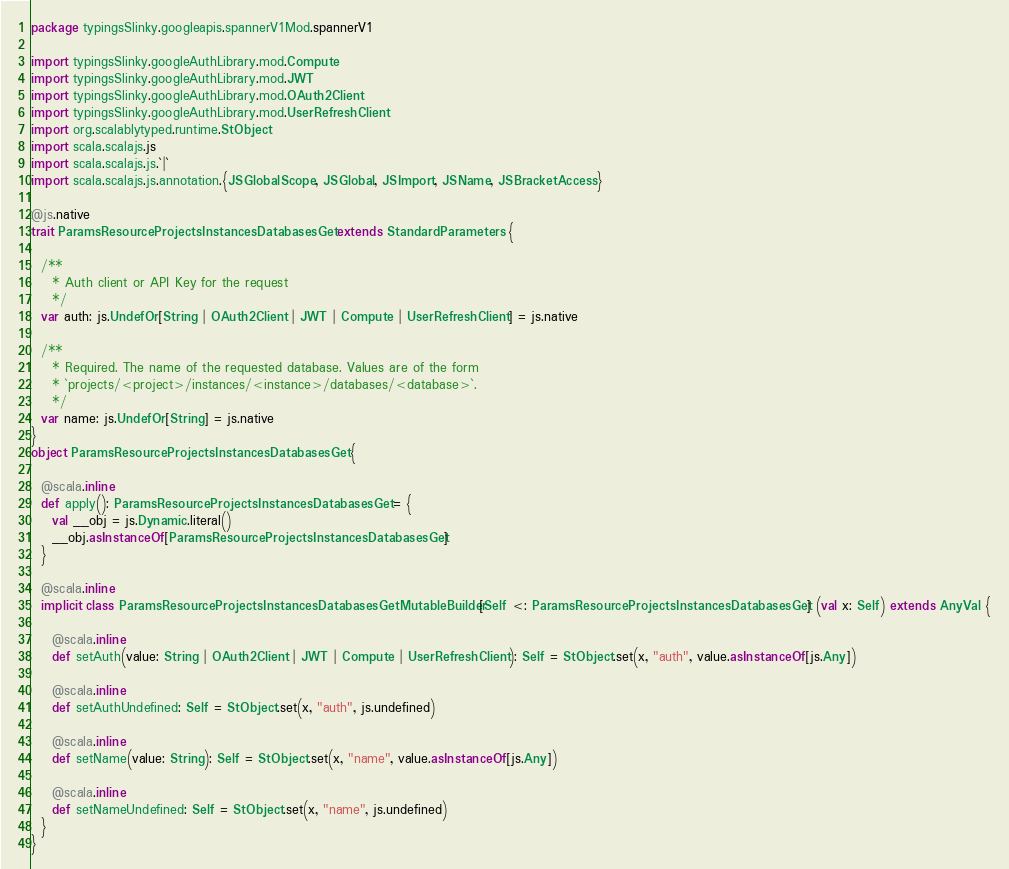<code> <loc_0><loc_0><loc_500><loc_500><_Scala_>package typingsSlinky.googleapis.spannerV1Mod.spannerV1

import typingsSlinky.googleAuthLibrary.mod.Compute
import typingsSlinky.googleAuthLibrary.mod.JWT
import typingsSlinky.googleAuthLibrary.mod.OAuth2Client
import typingsSlinky.googleAuthLibrary.mod.UserRefreshClient
import org.scalablytyped.runtime.StObject
import scala.scalajs.js
import scala.scalajs.js.`|`
import scala.scalajs.js.annotation.{JSGlobalScope, JSGlobal, JSImport, JSName, JSBracketAccess}

@js.native
trait ParamsResourceProjectsInstancesDatabasesGet extends StandardParameters {
  
  /**
    * Auth client or API Key for the request
    */
  var auth: js.UndefOr[String | OAuth2Client | JWT | Compute | UserRefreshClient] = js.native
  
  /**
    * Required. The name of the requested database. Values are of the form
    * `projects/<project>/instances/<instance>/databases/<database>`.
    */
  var name: js.UndefOr[String] = js.native
}
object ParamsResourceProjectsInstancesDatabasesGet {
  
  @scala.inline
  def apply(): ParamsResourceProjectsInstancesDatabasesGet = {
    val __obj = js.Dynamic.literal()
    __obj.asInstanceOf[ParamsResourceProjectsInstancesDatabasesGet]
  }
  
  @scala.inline
  implicit class ParamsResourceProjectsInstancesDatabasesGetMutableBuilder[Self <: ParamsResourceProjectsInstancesDatabasesGet] (val x: Self) extends AnyVal {
    
    @scala.inline
    def setAuth(value: String | OAuth2Client | JWT | Compute | UserRefreshClient): Self = StObject.set(x, "auth", value.asInstanceOf[js.Any])
    
    @scala.inline
    def setAuthUndefined: Self = StObject.set(x, "auth", js.undefined)
    
    @scala.inline
    def setName(value: String): Self = StObject.set(x, "name", value.asInstanceOf[js.Any])
    
    @scala.inline
    def setNameUndefined: Self = StObject.set(x, "name", js.undefined)
  }
}
</code> 